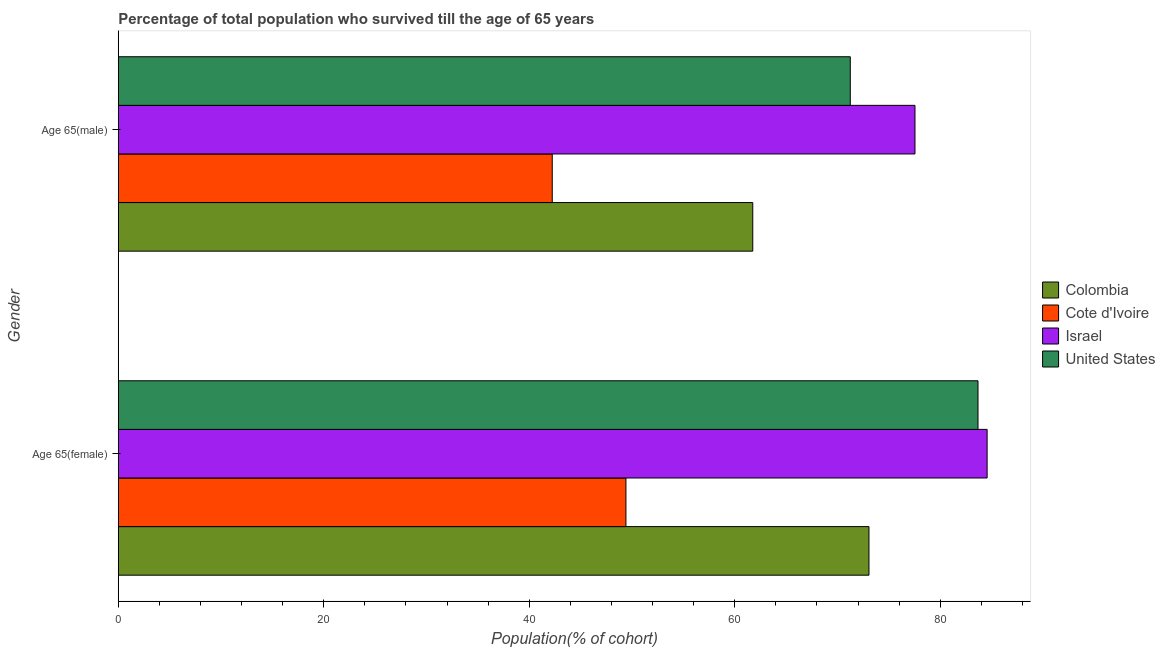How many groups of bars are there?
Offer a very short reply. 2. Are the number of bars per tick equal to the number of legend labels?
Your answer should be very brief. Yes. What is the label of the 2nd group of bars from the top?
Your answer should be very brief. Age 65(female). What is the percentage of female population who survived till age of 65 in Colombia?
Your answer should be compact. 73.06. Across all countries, what is the maximum percentage of female population who survived till age of 65?
Make the answer very short. 84.56. Across all countries, what is the minimum percentage of male population who survived till age of 65?
Ensure brevity in your answer.  42.24. In which country was the percentage of male population who survived till age of 65 minimum?
Provide a succinct answer. Cote d'Ivoire. What is the total percentage of female population who survived till age of 65 in the graph?
Your answer should be compact. 290.7. What is the difference between the percentage of female population who survived till age of 65 in Colombia and that in United States?
Keep it short and to the point. -10.61. What is the difference between the percentage of female population who survived till age of 65 in United States and the percentage of male population who survived till age of 65 in Colombia?
Provide a succinct answer. 21.92. What is the average percentage of male population who survived till age of 65 per country?
Your response must be concise. 63.19. What is the difference between the percentage of female population who survived till age of 65 and percentage of male population who survived till age of 65 in United States?
Your response must be concise. 12.43. What is the ratio of the percentage of male population who survived till age of 65 in United States to that in Cote d'Ivoire?
Give a very brief answer. 1.69. Is the percentage of male population who survived till age of 65 in United States less than that in Cote d'Ivoire?
Provide a short and direct response. No. What does the 1st bar from the top in Age 65(male) represents?
Make the answer very short. United States. What does the 1st bar from the bottom in Age 65(male) represents?
Offer a very short reply. Colombia. Are all the bars in the graph horizontal?
Keep it short and to the point. Yes. What is the difference between two consecutive major ticks on the X-axis?
Provide a short and direct response. 20. Where does the legend appear in the graph?
Make the answer very short. Center right. What is the title of the graph?
Provide a short and direct response. Percentage of total population who survived till the age of 65 years. Does "Mali" appear as one of the legend labels in the graph?
Your answer should be very brief. No. What is the label or title of the X-axis?
Keep it short and to the point. Population(% of cohort). What is the label or title of the Y-axis?
Offer a terse response. Gender. What is the Population(% of cohort) of Colombia in Age 65(female)?
Offer a very short reply. 73.06. What is the Population(% of cohort) in Cote d'Ivoire in Age 65(female)?
Offer a terse response. 49.41. What is the Population(% of cohort) in Israel in Age 65(female)?
Your answer should be very brief. 84.56. What is the Population(% of cohort) of United States in Age 65(female)?
Provide a succinct answer. 83.67. What is the Population(% of cohort) of Colombia in Age 65(male)?
Your answer should be very brief. 61.75. What is the Population(% of cohort) of Cote d'Ivoire in Age 65(male)?
Your answer should be very brief. 42.24. What is the Population(% of cohort) in Israel in Age 65(male)?
Keep it short and to the point. 77.54. What is the Population(% of cohort) of United States in Age 65(male)?
Your response must be concise. 71.24. Across all Gender, what is the maximum Population(% of cohort) in Colombia?
Give a very brief answer. 73.06. Across all Gender, what is the maximum Population(% of cohort) in Cote d'Ivoire?
Keep it short and to the point. 49.41. Across all Gender, what is the maximum Population(% of cohort) in Israel?
Your response must be concise. 84.56. Across all Gender, what is the maximum Population(% of cohort) in United States?
Your answer should be very brief. 83.67. Across all Gender, what is the minimum Population(% of cohort) in Colombia?
Keep it short and to the point. 61.75. Across all Gender, what is the minimum Population(% of cohort) of Cote d'Ivoire?
Your answer should be very brief. 42.24. Across all Gender, what is the minimum Population(% of cohort) in Israel?
Keep it short and to the point. 77.54. Across all Gender, what is the minimum Population(% of cohort) in United States?
Keep it short and to the point. 71.24. What is the total Population(% of cohort) in Colombia in the graph?
Provide a succinct answer. 134.81. What is the total Population(% of cohort) of Cote d'Ivoire in the graph?
Give a very brief answer. 91.64. What is the total Population(% of cohort) of Israel in the graph?
Your response must be concise. 162.1. What is the total Population(% of cohort) in United States in the graph?
Make the answer very short. 154.91. What is the difference between the Population(% of cohort) in Colombia in Age 65(female) and that in Age 65(male)?
Make the answer very short. 11.31. What is the difference between the Population(% of cohort) in Cote d'Ivoire in Age 65(female) and that in Age 65(male)?
Your response must be concise. 7.17. What is the difference between the Population(% of cohort) of Israel in Age 65(female) and that in Age 65(male)?
Provide a succinct answer. 7.02. What is the difference between the Population(% of cohort) of United States in Age 65(female) and that in Age 65(male)?
Ensure brevity in your answer.  12.43. What is the difference between the Population(% of cohort) in Colombia in Age 65(female) and the Population(% of cohort) in Cote d'Ivoire in Age 65(male)?
Your response must be concise. 30.83. What is the difference between the Population(% of cohort) of Colombia in Age 65(female) and the Population(% of cohort) of Israel in Age 65(male)?
Your answer should be compact. -4.48. What is the difference between the Population(% of cohort) of Colombia in Age 65(female) and the Population(% of cohort) of United States in Age 65(male)?
Your response must be concise. 1.82. What is the difference between the Population(% of cohort) in Cote d'Ivoire in Age 65(female) and the Population(% of cohort) in Israel in Age 65(male)?
Provide a succinct answer. -28.13. What is the difference between the Population(% of cohort) of Cote d'Ivoire in Age 65(female) and the Population(% of cohort) of United States in Age 65(male)?
Offer a terse response. -21.83. What is the difference between the Population(% of cohort) of Israel in Age 65(female) and the Population(% of cohort) of United States in Age 65(male)?
Provide a succinct answer. 13.32. What is the average Population(% of cohort) of Colombia per Gender?
Keep it short and to the point. 67.41. What is the average Population(% of cohort) in Cote d'Ivoire per Gender?
Offer a terse response. 45.82. What is the average Population(% of cohort) of Israel per Gender?
Make the answer very short. 81.05. What is the average Population(% of cohort) in United States per Gender?
Offer a very short reply. 77.46. What is the difference between the Population(% of cohort) of Colombia and Population(% of cohort) of Cote d'Ivoire in Age 65(female)?
Ensure brevity in your answer.  23.65. What is the difference between the Population(% of cohort) of Colombia and Population(% of cohort) of Israel in Age 65(female)?
Your answer should be compact. -11.5. What is the difference between the Population(% of cohort) of Colombia and Population(% of cohort) of United States in Age 65(female)?
Offer a very short reply. -10.61. What is the difference between the Population(% of cohort) of Cote d'Ivoire and Population(% of cohort) of Israel in Age 65(female)?
Offer a terse response. -35.15. What is the difference between the Population(% of cohort) in Cote d'Ivoire and Population(% of cohort) in United States in Age 65(female)?
Offer a very short reply. -34.27. What is the difference between the Population(% of cohort) in Israel and Population(% of cohort) in United States in Age 65(female)?
Offer a terse response. 0.89. What is the difference between the Population(% of cohort) of Colombia and Population(% of cohort) of Cote d'Ivoire in Age 65(male)?
Make the answer very short. 19.52. What is the difference between the Population(% of cohort) of Colombia and Population(% of cohort) of Israel in Age 65(male)?
Provide a short and direct response. -15.79. What is the difference between the Population(% of cohort) in Colombia and Population(% of cohort) in United States in Age 65(male)?
Make the answer very short. -9.49. What is the difference between the Population(% of cohort) in Cote d'Ivoire and Population(% of cohort) in Israel in Age 65(male)?
Make the answer very short. -35.3. What is the difference between the Population(% of cohort) in Cote d'Ivoire and Population(% of cohort) in United States in Age 65(male)?
Ensure brevity in your answer.  -29.01. What is the difference between the Population(% of cohort) in Israel and Population(% of cohort) in United States in Age 65(male)?
Ensure brevity in your answer.  6.3. What is the ratio of the Population(% of cohort) of Colombia in Age 65(female) to that in Age 65(male)?
Offer a terse response. 1.18. What is the ratio of the Population(% of cohort) of Cote d'Ivoire in Age 65(female) to that in Age 65(male)?
Your answer should be compact. 1.17. What is the ratio of the Population(% of cohort) in Israel in Age 65(female) to that in Age 65(male)?
Your answer should be compact. 1.09. What is the ratio of the Population(% of cohort) of United States in Age 65(female) to that in Age 65(male)?
Offer a terse response. 1.17. What is the difference between the highest and the second highest Population(% of cohort) in Colombia?
Keep it short and to the point. 11.31. What is the difference between the highest and the second highest Population(% of cohort) of Cote d'Ivoire?
Offer a terse response. 7.17. What is the difference between the highest and the second highest Population(% of cohort) in Israel?
Your answer should be compact. 7.02. What is the difference between the highest and the second highest Population(% of cohort) in United States?
Ensure brevity in your answer.  12.43. What is the difference between the highest and the lowest Population(% of cohort) in Colombia?
Your answer should be very brief. 11.31. What is the difference between the highest and the lowest Population(% of cohort) in Cote d'Ivoire?
Your answer should be very brief. 7.17. What is the difference between the highest and the lowest Population(% of cohort) in Israel?
Your response must be concise. 7.02. What is the difference between the highest and the lowest Population(% of cohort) in United States?
Your answer should be compact. 12.43. 